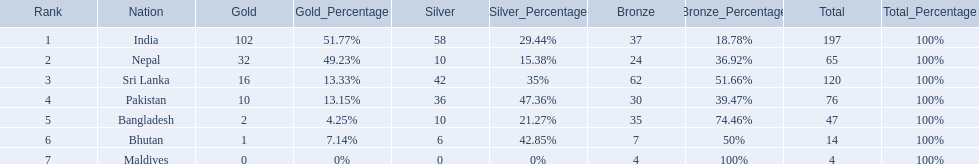How many gold medals were won by the teams? 102, 32, 16, 10, 2, 1, 0. What country won no gold medals? Maldives. 